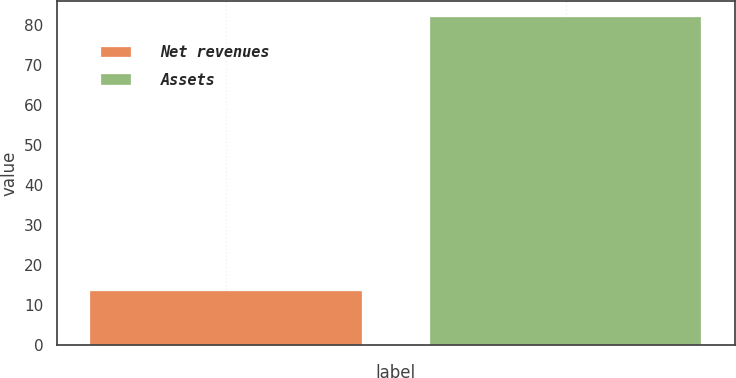<chart> <loc_0><loc_0><loc_500><loc_500><bar_chart><fcel>Net revenues<fcel>Assets<nl><fcel>13.5<fcel>81.9<nl></chart> 